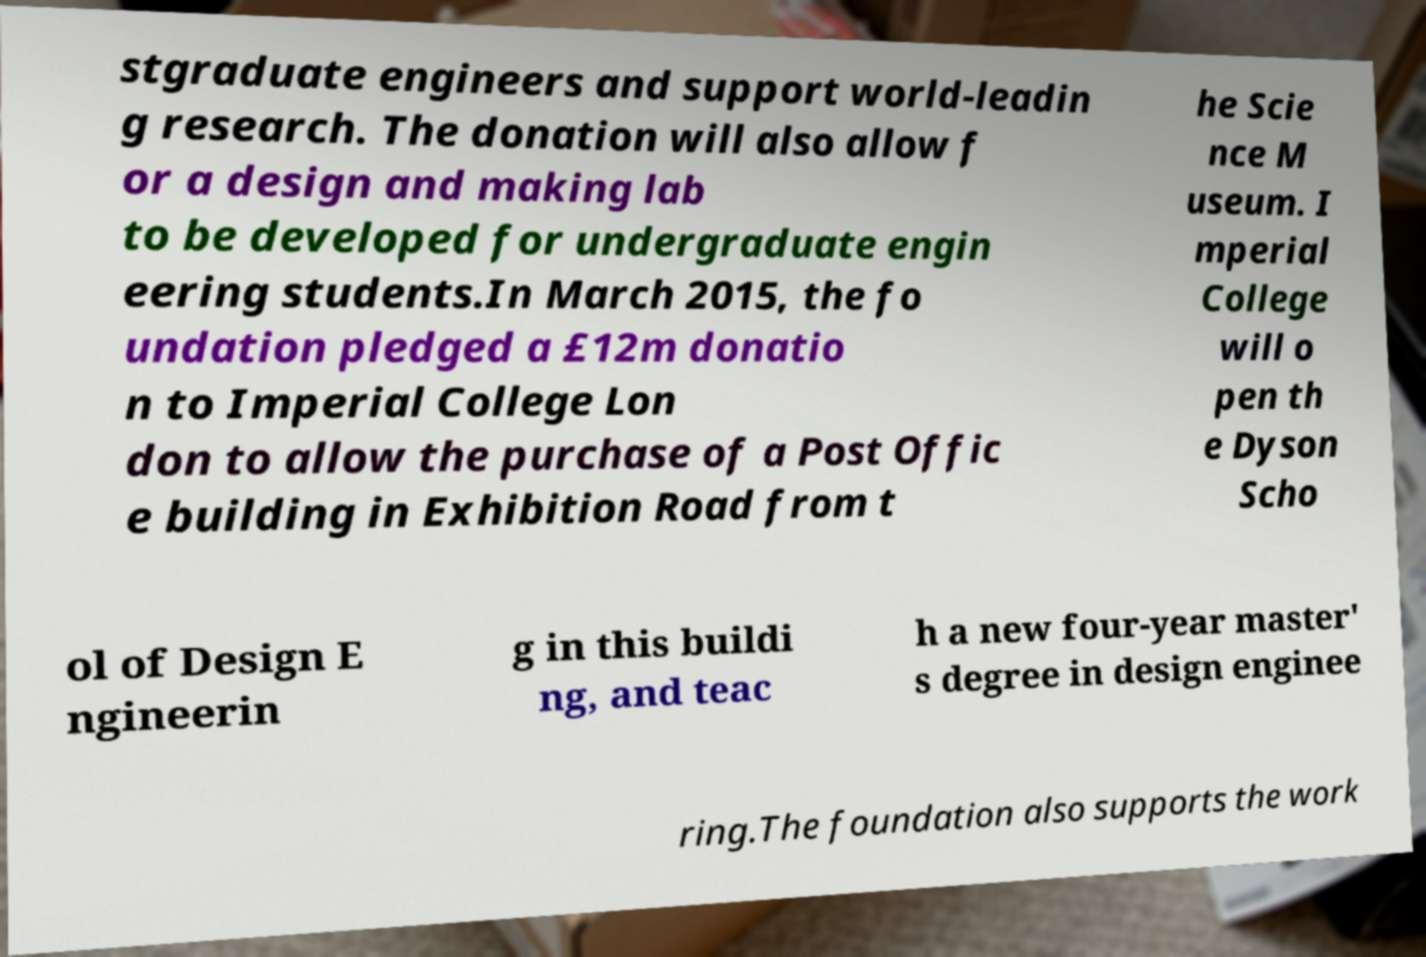Can you accurately transcribe the text from the provided image for me? stgraduate engineers and support world-leadin g research. The donation will also allow f or a design and making lab to be developed for undergraduate engin eering students.In March 2015, the fo undation pledged a £12m donatio n to Imperial College Lon don to allow the purchase of a Post Offic e building in Exhibition Road from t he Scie nce M useum. I mperial College will o pen th e Dyson Scho ol of Design E ngineerin g in this buildi ng, and teac h a new four-year master' s degree in design enginee ring.The foundation also supports the work 